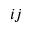Convert formula to latex. <formula><loc_0><loc_0><loc_500><loc_500>{ i j }</formula> 